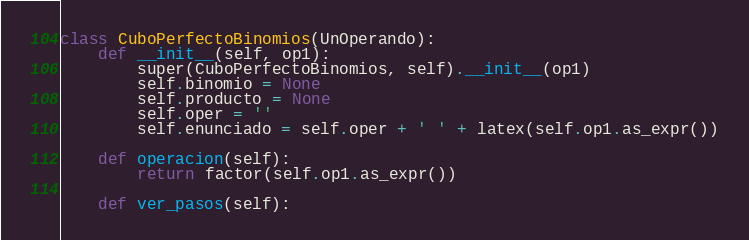Convert code to text. <code><loc_0><loc_0><loc_500><loc_500><_Python_>
class CuboPerfectoBinomios(UnOperando):
    def __init__(self, op1):
        super(CuboPerfectoBinomios, self).__init__(op1)
        self.binomio = None
        self.producto = None
        self.oper = ''
        self.enunciado = self.oper + ' ' + latex(self.op1.as_expr())

    def operacion(self):
        return factor(self.op1.as_expr())

    def ver_pasos(self):</code> 